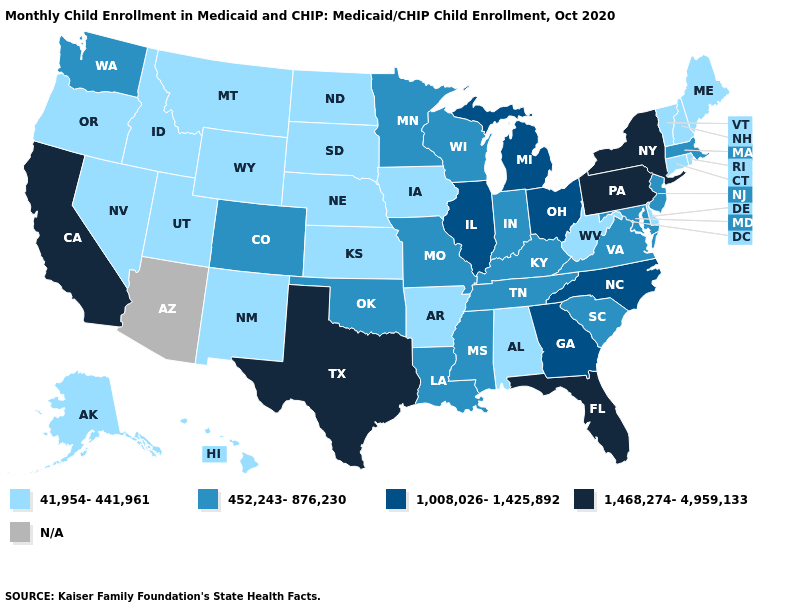What is the highest value in the USA?
Short answer required. 1,468,274-4,959,133. Does Illinois have the lowest value in the MidWest?
Be succinct. No. Among the states that border Texas , which have the lowest value?
Short answer required. Arkansas, New Mexico. Name the states that have a value in the range 452,243-876,230?
Concise answer only. Colorado, Indiana, Kentucky, Louisiana, Maryland, Massachusetts, Minnesota, Mississippi, Missouri, New Jersey, Oklahoma, South Carolina, Tennessee, Virginia, Washington, Wisconsin. Name the states that have a value in the range N/A?
Be succinct. Arizona. Which states hav the highest value in the Northeast?
Short answer required. New York, Pennsylvania. What is the highest value in the MidWest ?
Concise answer only. 1,008,026-1,425,892. Among the states that border Wyoming , does Colorado have the highest value?
Write a very short answer. Yes. Name the states that have a value in the range 1,468,274-4,959,133?
Keep it brief. California, Florida, New York, Pennsylvania, Texas. Which states have the highest value in the USA?
Keep it brief. California, Florida, New York, Pennsylvania, Texas. Among the states that border New Jersey , does Pennsylvania have the highest value?
Answer briefly. Yes. Name the states that have a value in the range 1,008,026-1,425,892?
Answer briefly. Georgia, Illinois, Michigan, North Carolina, Ohio. What is the value of Indiana?
Answer briefly. 452,243-876,230. 